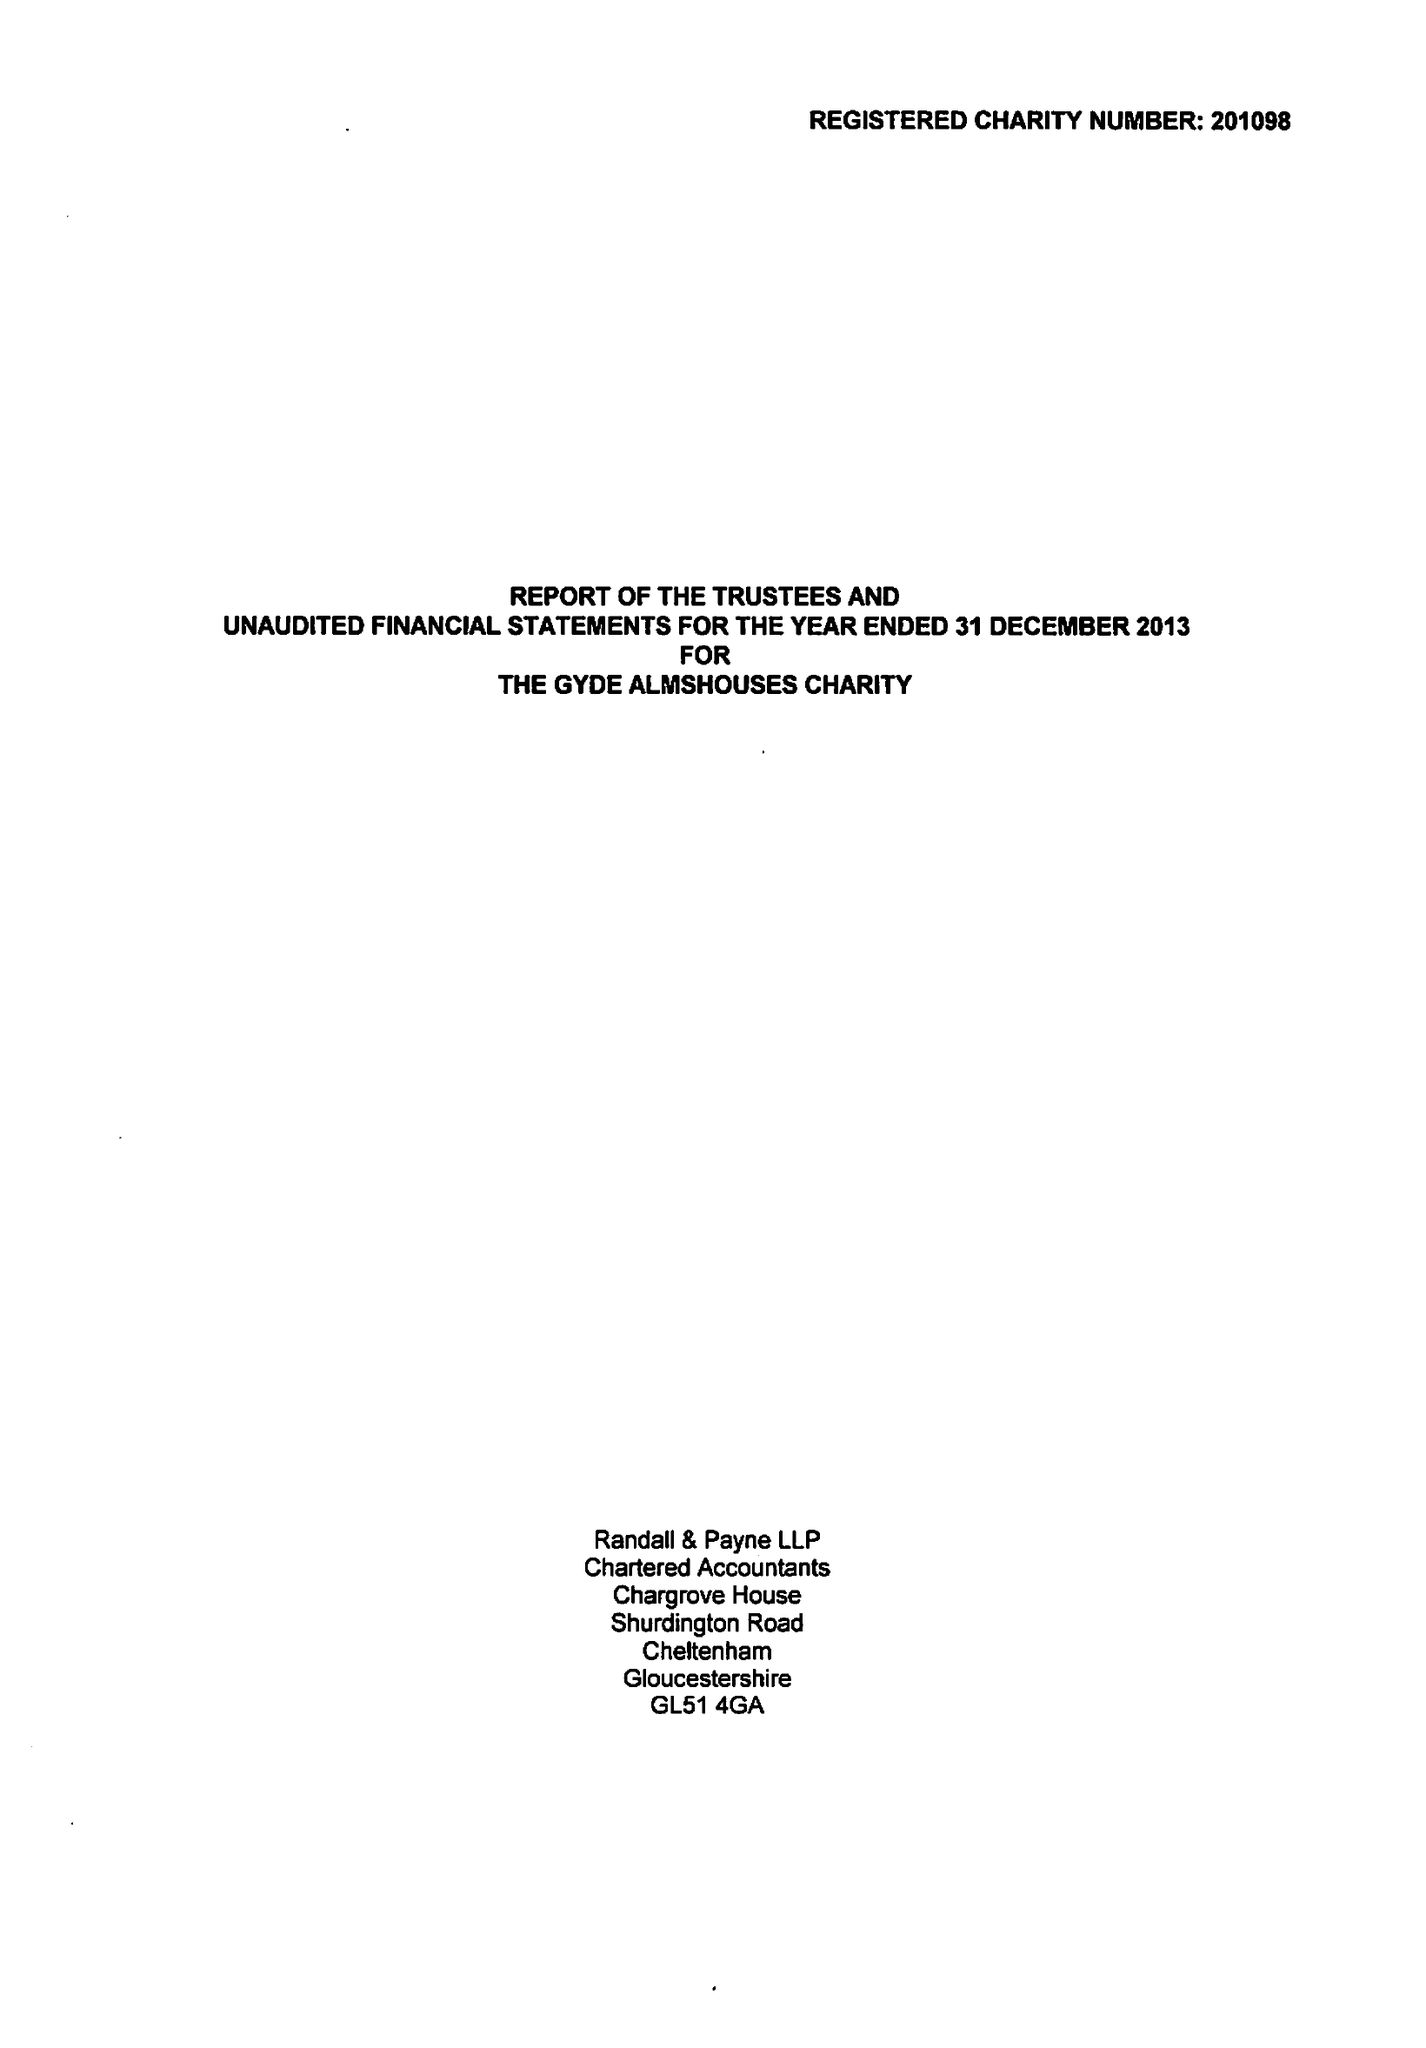What is the value for the address__street_line?
Answer the question using a single word or phrase. None 